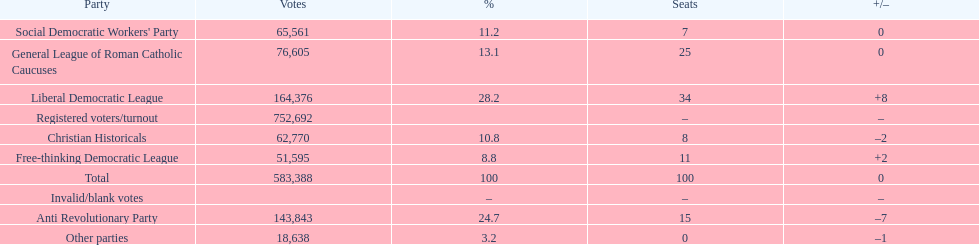How many votes were counted as invalid or blank votes? 0. 